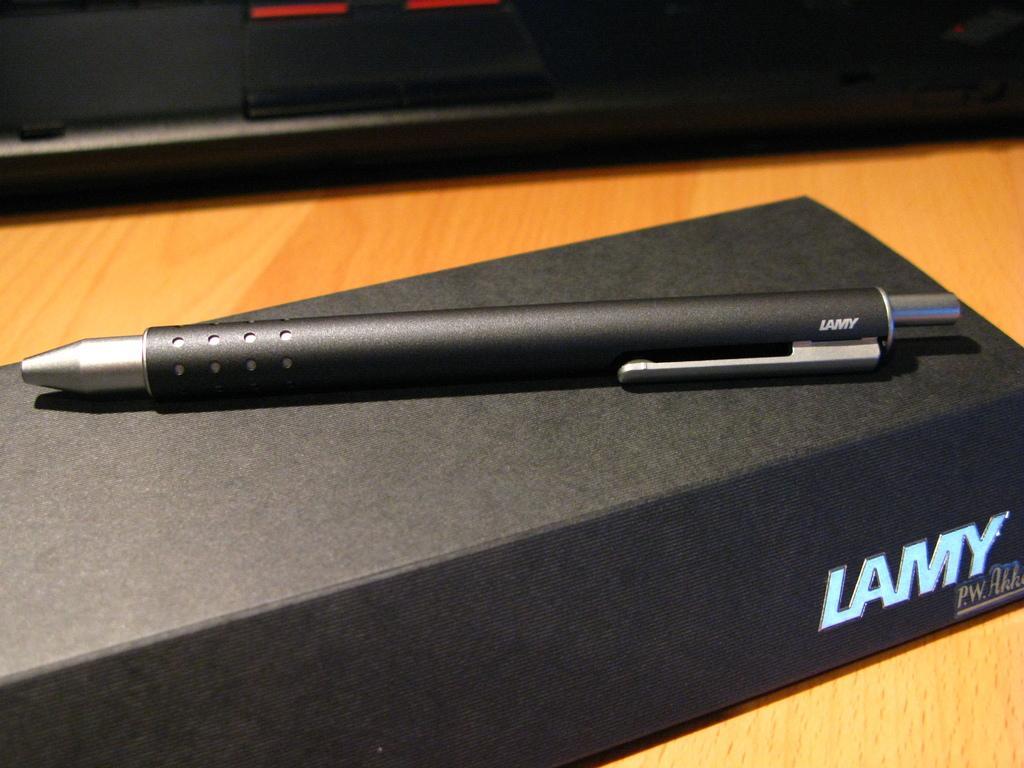How would you summarize this image in a sentence or two? In this image, we can see a pen is placed on the black box. Background we can see a wooden surface. Top of the image, we can see a black color object. 